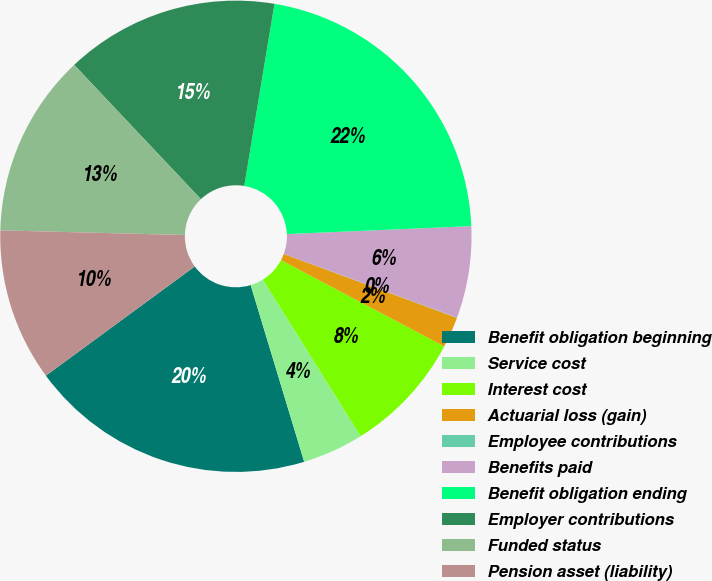Convert chart. <chart><loc_0><loc_0><loc_500><loc_500><pie_chart><fcel>Benefit obligation beginning<fcel>Service cost<fcel>Interest cost<fcel>Actuarial loss (gain)<fcel>Employee contributions<fcel>Benefits paid<fcel>Benefit obligation ending<fcel>Employer contributions<fcel>Funded status<fcel>Pension asset (liability)<nl><fcel>19.6%<fcel>4.2%<fcel>8.38%<fcel>2.11%<fcel>0.02%<fcel>6.29%<fcel>21.69%<fcel>14.65%<fcel>12.56%<fcel>10.47%<nl></chart> 